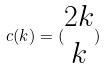Convert formula to latex. <formula><loc_0><loc_0><loc_500><loc_500>c ( k ) = ( \begin{matrix} 2 k \\ k \end{matrix} )</formula> 